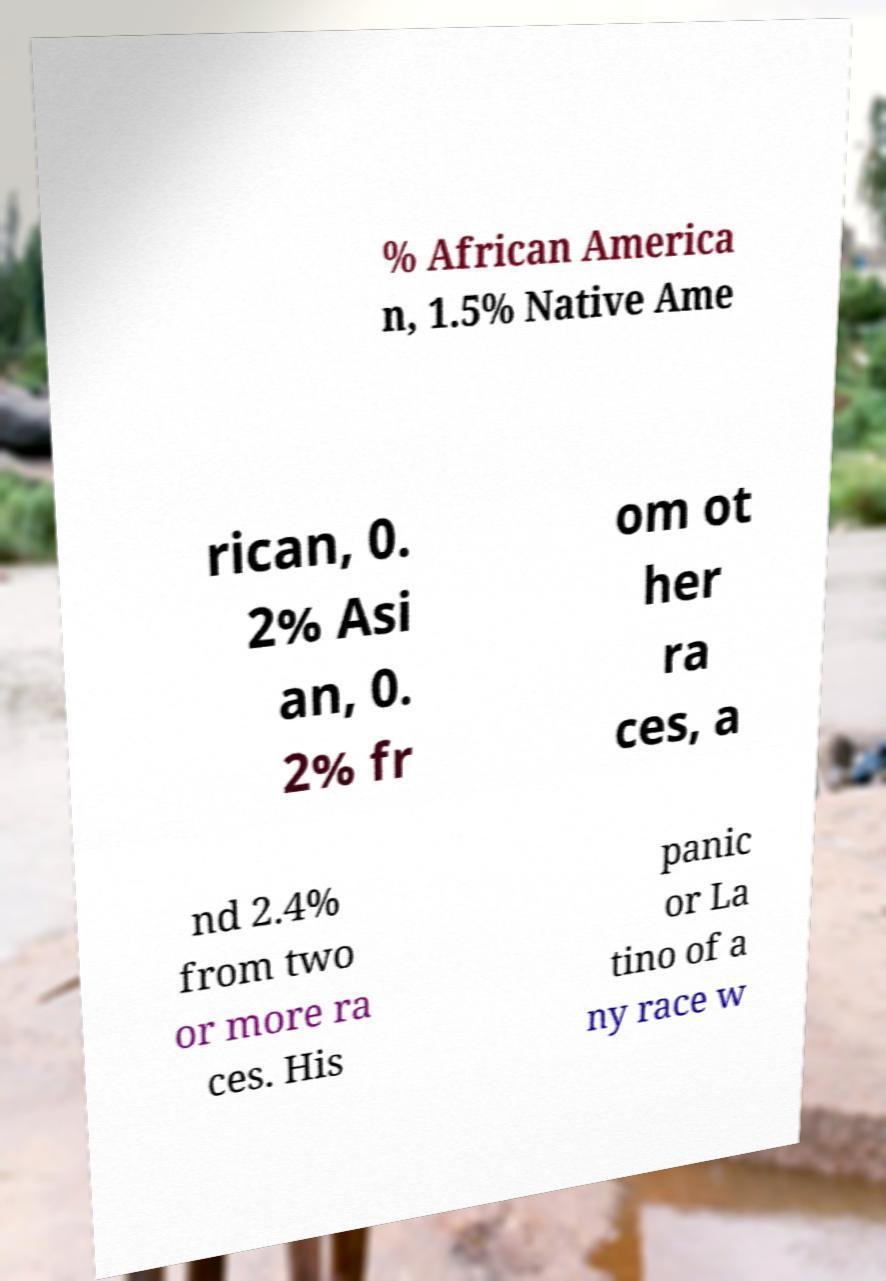Can you read and provide the text displayed in the image?This photo seems to have some interesting text. Can you extract and type it out for me? % African America n, 1.5% Native Ame rican, 0. 2% Asi an, 0. 2% fr om ot her ra ces, a nd 2.4% from two or more ra ces. His panic or La tino of a ny race w 